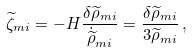<formula> <loc_0><loc_0><loc_500><loc_500>\widetilde { \zeta } _ { m i } = - H \frac { \delta \widetilde { \rho } _ { m i } } { \dot { \widetilde { \rho } } _ { m i } } = \frac { \delta \widetilde { \rho } _ { m i } } { 3 \widetilde { \rho } _ { m i } } \, ,</formula> 